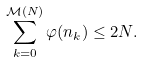<formula> <loc_0><loc_0><loc_500><loc_500>\sum _ { k = 0 } ^ { \mathcal { M } ( N ) } \varphi ( n _ { k } ) \leq 2 N .</formula> 